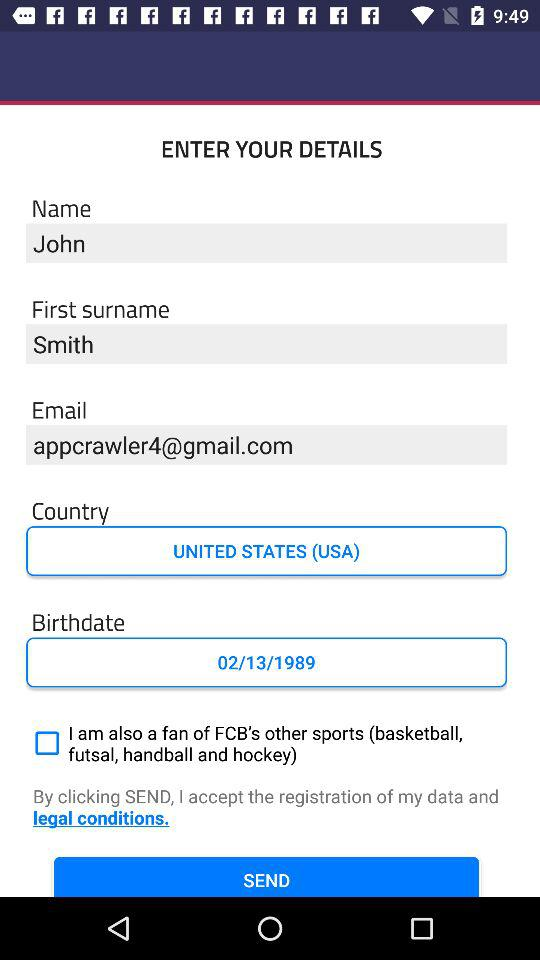What is the status of "I am also a fan of FCB's other sports (basketball, futsal, handball and hockey)"? The status is "off". 